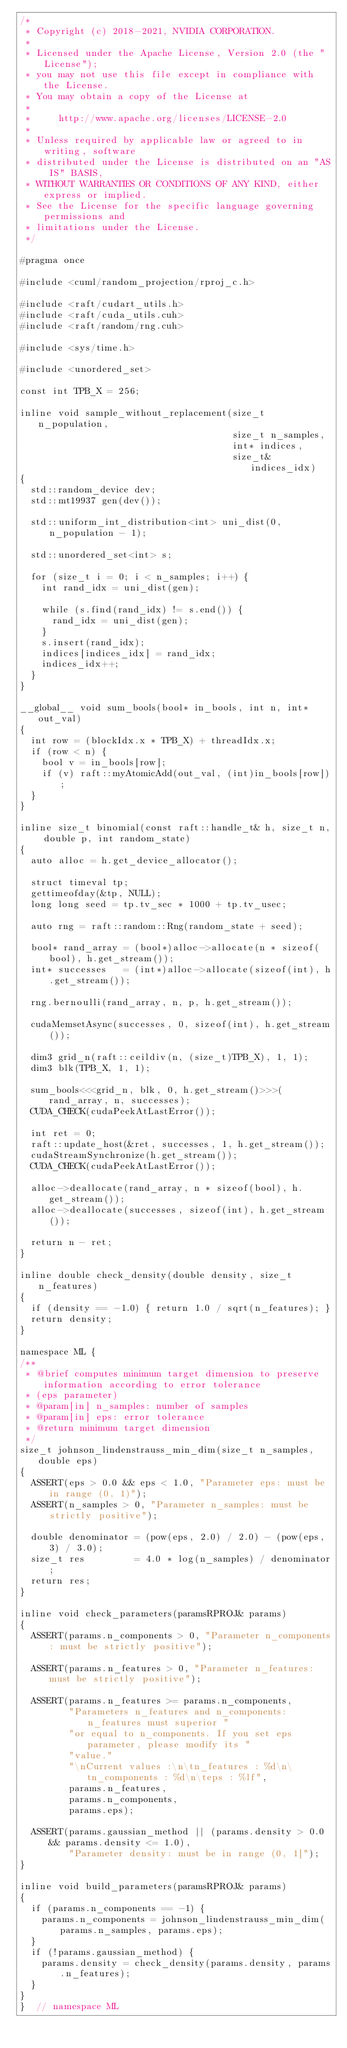Convert code to text. <code><loc_0><loc_0><loc_500><loc_500><_Cuda_>/*
 * Copyright (c) 2018-2021, NVIDIA CORPORATION.
 *
 * Licensed under the Apache License, Version 2.0 (the "License");
 * you may not use this file except in compliance with the License.
 * You may obtain a copy of the License at
 *
 *     http://www.apache.org/licenses/LICENSE-2.0
 *
 * Unless required by applicable law or agreed to in writing, software
 * distributed under the License is distributed on an "AS IS" BASIS,
 * WITHOUT WARRANTIES OR CONDITIONS OF ANY KIND, either express or implied.
 * See the License for the specific language governing permissions and
 * limitations under the License.
 */

#pragma once

#include <cuml/random_projection/rproj_c.h>

#include <raft/cudart_utils.h>
#include <raft/cuda_utils.cuh>
#include <raft/random/rng.cuh>

#include <sys/time.h>

#include <unordered_set>

const int TPB_X = 256;

inline void sample_without_replacement(size_t n_population,
                                       size_t n_samples,
                                       int* indices,
                                       size_t& indices_idx)
{
  std::random_device dev;
  std::mt19937 gen(dev());

  std::uniform_int_distribution<int> uni_dist(0, n_population - 1);

  std::unordered_set<int> s;

  for (size_t i = 0; i < n_samples; i++) {
    int rand_idx = uni_dist(gen);

    while (s.find(rand_idx) != s.end()) {
      rand_idx = uni_dist(gen);
    }
    s.insert(rand_idx);
    indices[indices_idx] = rand_idx;
    indices_idx++;
  }
}

__global__ void sum_bools(bool* in_bools, int n, int* out_val)
{
  int row = (blockIdx.x * TPB_X) + threadIdx.x;
  if (row < n) {
    bool v = in_bools[row];
    if (v) raft::myAtomicAdd(out_val, (int)in_bools[row]);
  }
}

inline size_t binomial(const raft::handle_t& h, size_t n, double p, int random_state)
{
  auto alloc = h.get_device_allocator();

  struct timeval tp;
  gettimeofday(&tp, NULL);
  long long seed = tp.tv_sec * 1000 + tp.tv_usec;

  auto rng = raft::random::Rng(random_state + seed);

  bool* rand_array = (bool*)alloc->allocate(n * sizeof(bool), h.get_stream());
  int* successes   = (int*)alloc->allocate(sizeof(int), h.get_stream());

  rng.bernoulli(rand_array, n, p, h.get_stream());

  cudaMemsetAsync(successes, 0, sizeof(int), h.get_stream());

  dim3 grid_n(raft::ceildiv(n, (size_t)TPB_X), 1, 1);
  dim3 blk(TPB_X, 1, 1);

  sum_bools<<<grid_n, blk, 0, h.get_stream()>>>(rand_array, n, successes);
  CUDA_CHECK(cudaPeekAtLastError());

  int ret = 0;
  raft::update_host(&ret, successes, 1, h.get_stream());
  cudaStreamSynchronize(h.get_stream());
  CUDA_CHECK(cudaPeekAtLastError());

  alloc->deallocate(rand_array, n * sizeof(bool), h.get_stream());
  alloc->deallocate(successes, sizeof(int), h.get_stream());

  return n - ret;
}

inline double check_density(double density, size_t n_features)
{
  if (density == -1.0) { return 1.0 / sqrt(n_features); }
  return density;
}

namespace ML {
/**
 * @brief computes minimum target dimension to preserve information according to error tolerance
 * (eps parameter)
 * @param[in] n_samples: number of samples
 * @param[in] eps: error tolerance
 * @return minimum target dimension
 */
size_t johnson_lindenstrauss_min_dim(size_t n_samples, double eps)
{
  ASSERT(eps > 0.0 && eps < 1.0, "Parameter eps: must be in range (0, 1)");
  ASSERT(n_samples > 0, "Parameter n_samples: must be strictly positive");

  double denominator = (pow(eps, 2.0) / 2.0) - (pow(eps, 3) / 3.0);
  size_t res         = 4.0 * log(n_samples) / denominator;
  return res;
}

inline void check_parameters(paramsRPROJ& params)
{
  ASSERT(params.n_components > 0, "Parameter n_components: must be strictly positive");

  ASSERT(params.n_features > 0, "Parameter n_features: must be strictly positive");

  ASSERT(params.n_features >= params.n_components,
         "Parameters n_features and n_components: n_features must superior "
         "or equal to n_components. If you set eps parameter, please modify its "
         "value."
         "\nCurrent values :\n\tn_features : %d\n\tn_components : %d\n\teps : %lf",
         params.n_features,
         params.n_components,
         params.eps);

  ASSERT(params.gaussian_method || (params.density > 0.0 && params.density <= 1.0),
         "Parameter density: must be in range (0, 1]");
}

inline void build_parameters(paramsRPROJ& params)
{
  if (params.n_components == -1) {
    params.n_components = johnson_lindenstrauss_min_dim(params.n_samples, params.eps);
  }
  if (!params.gaussian_method) {
    params.density = check_density(params.density, params.n_features);
  }
}
}  // namespace ML
</code> 